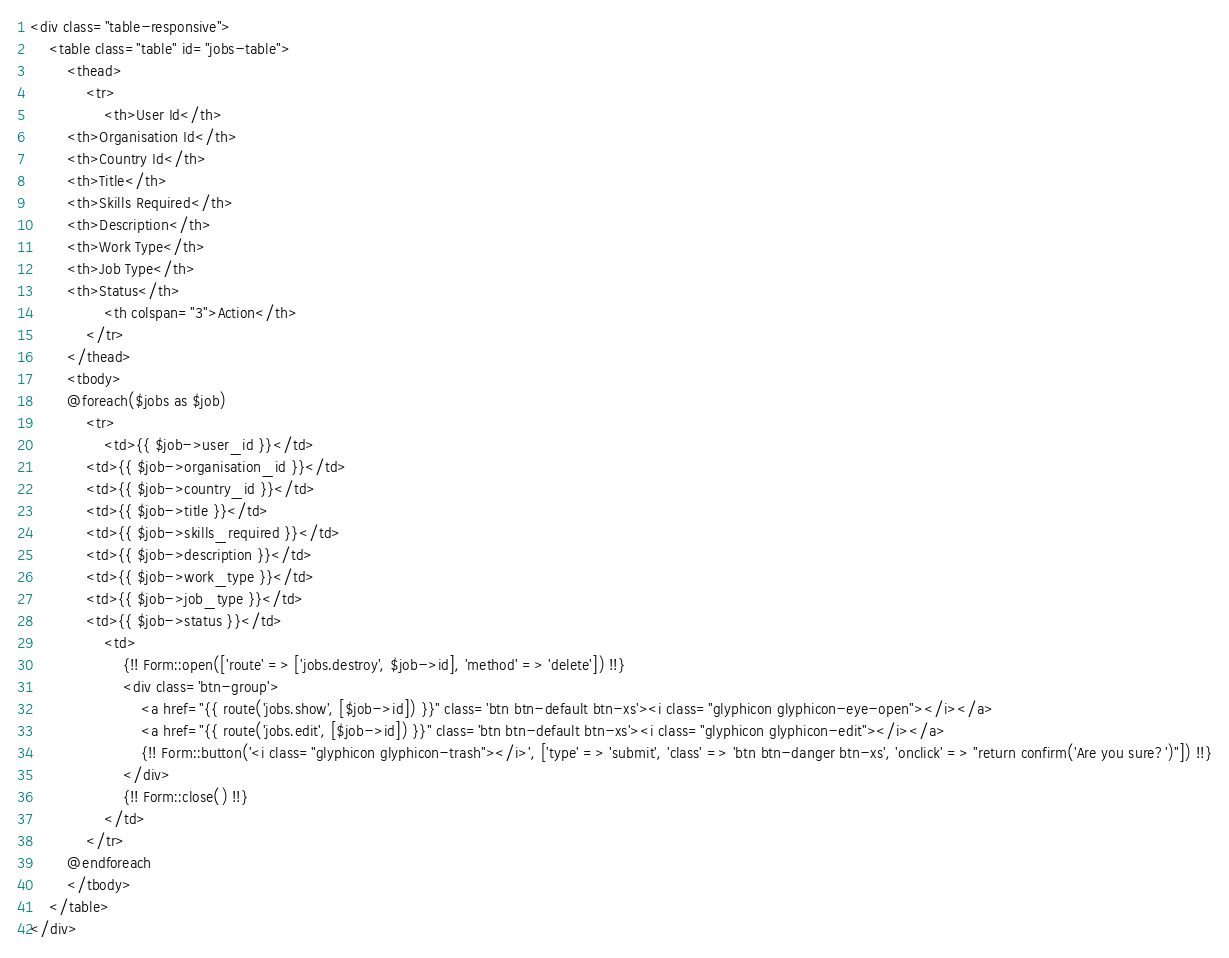<code> <loc_0><loc_0><loc_500><loc_500><_PHP_><div class="table-responsive">
    <table class="table" id="jobs-table">
        <thead>
            <tr>
                <th>User Id</th>
        <th>Organisation Id</th>
        <th>Country Id</th>
        <th>Title</th>
        <th>Skills Required</th>
        <th>Description</th>
        <th>Work Type</th>
        <th>Job Type</th>
        <th>Status</th>
                <th colspan="3">Action</th>
            </tr>
        </thead>
        <tbody>
        @foreach($jobs as $job)
            <tr>
                <td>{{ $job->user_id }}</td>
            <td>{{ $job->organisation_id }}</td>
            <td>{{ $job->country_id }}</td>
            <td>{{ $job->title }}</td>
            <td>{{ $job->skills_required }}</td>
            <td>{{ $job->description }}</td>
            <td>{{ $job->work_type }}</td>
            <td>{{ $job->job_type }}</td>
            <td>{{ $job->status }}</td>
                <td>
                    {!! Form::open(['route' => ['jobs.destroy', $job->id], 'method' => 'delete']) !!}
                    <div class='btn-group'>
                        <a href="{{ route('jobs.show', [$job->id]) }}" class='btn btn-default btn-xs'><i class="glyphicon glyphicon-eye-open"></i></a>
                        <a href="{{ route('jobs.edit', [$job->id]) }}" class='btn btn-default btn-xs'><i class="glyphicon glyphicon-edit"></i></a>
                        {!! Form::button('<i class="glyphicon glyphicon-trash"></i>', ['type' => 'submit', 'class' => 'btn btn-danger btn-xs', 'onclick' => "return confirm('Are you sure?')"]) !!}
                    </div>
                    {!! Form::close() !!}
                </td>
            </tr>
        @endforeach
        </tbody>
    </table>
</div>
</code> 